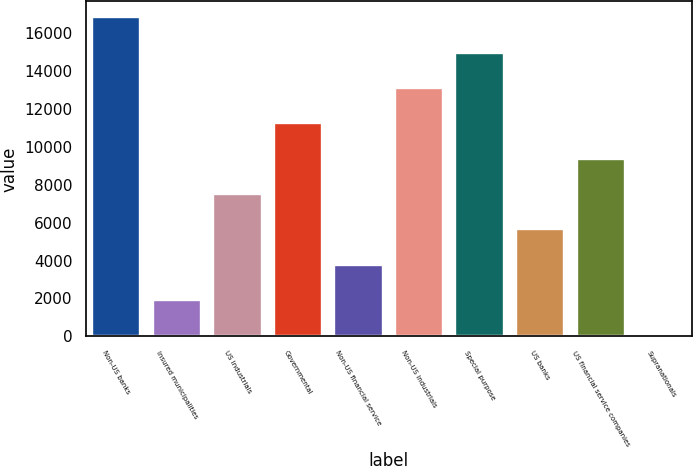Convert chart. <chart><loc_0><loc_0><loc_500><loc_500><bar_chart><fcel>Non-US banks<fcel>Insured municipalities<fcel>US industrials<fcel>Governmental<fcel>Non-US financial service<fcel>Non-US industrials<fcel>Special purpose<fcel>US banks<fcel>US financial service companies<fcel>Supranationals<nl><fcel>16830.6<fcel>1915.4<fcel>7508.6<fcel>11237.4<fcel>3779.8<fcel>13101.8<fcel>14966.2<fcel>5644.2<fcel>9373<fcel>51<nl></chart> 